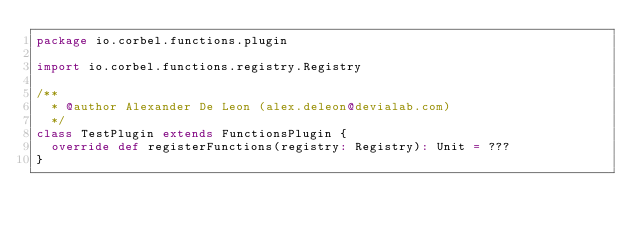<code> <loc_0><loc_0><loc_500><loc_500><_Scala_>package io.corbel.functions.plugin

import io.corbel.functions.registry.Registry

/**
  * @author Alexander De Leon (alex.deleon@devialab.com)
  */
class TestPlugin extends FunctionsPlugin {
  override def registerFunctions(registry: Registry): Unit = ???
}
</code> 